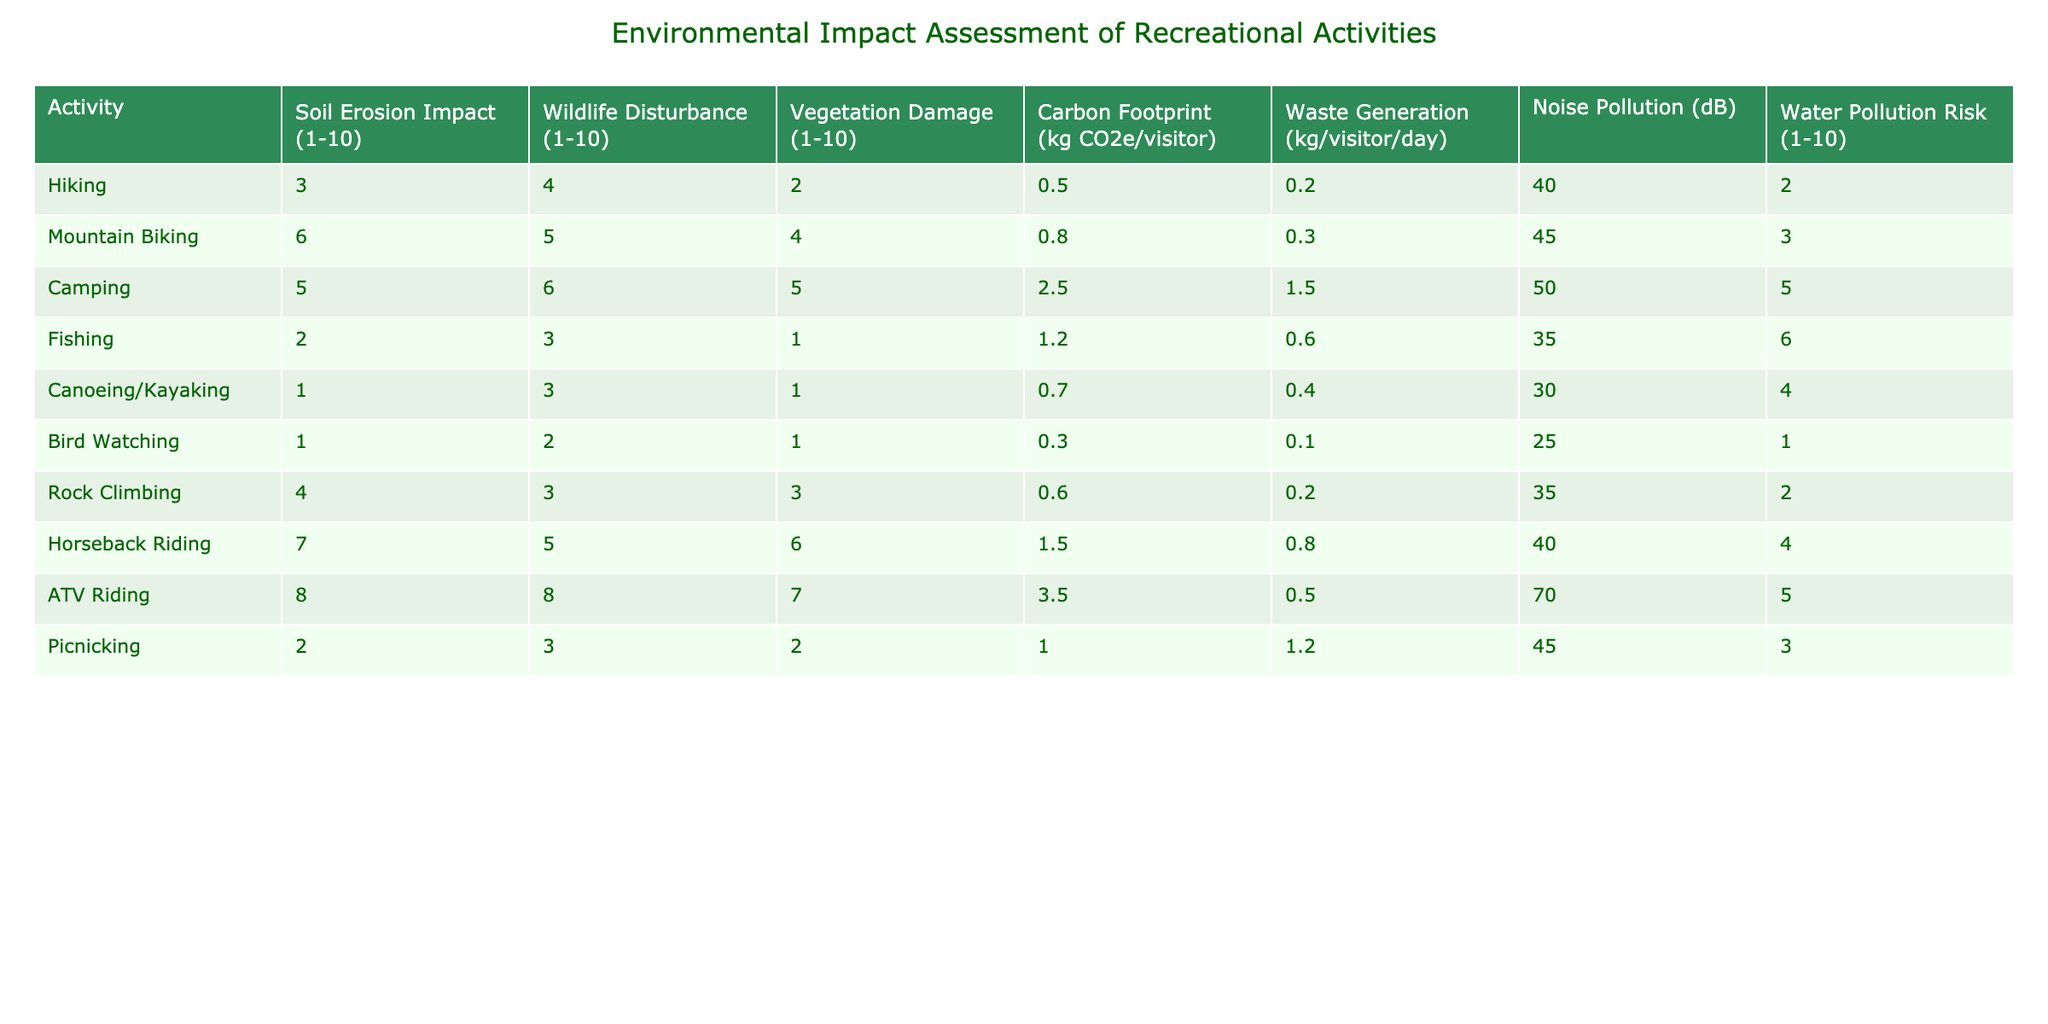What is the soil erosion impact of mountain biking? The table shows that the soil erosion impact rating for mountain biking is 6.
Answer: 6 Which activity has the highest carbon footprint per visitor? By examining the carbon footprint values in the table, ATV riding has the highest value at 3.5 kg CO2e per visitor.
Answer: 3.5 What is the average waste generation per visitor for all activities listed? First, sum the waste generation values: (0.2 + 0.3 + 1.5 + 0.6 + 0.4 + 0.1 + 0.2 + 0.8 + 0.5 + 1.2) = 5.8. There are 10 activities, so the average is 5.8 / 10 = 0.58 kg/visitor/day.
Answer: 0.58 kg/visitor/day Does bird watching have a higher wildlife disturbance impact than fishing? The wildlife disturbance impact for bird watching is 2, while for fishing it is 3. Since 2 is not greater than 3, the statement is false.
Answer: No Which activity generates the least noise pollution? The noise pollution levels for each activity reveal that bird watching has the lowest rating at 25 dB.
Answer: 25 dB What is the total vegetation damage score for horseback riding and camping combined? The vegetation damage for horseback riding is 6 and for camping is 5. Adding them together gives 6 + 5 = 11.
Answer: 11 How many activities have a water pollution risk rating of 5 or higher? Assessing the water pollution risk ratings, camping, ATV riding, and fishing have ratings of 5, thus there are 3 activities with a rating of 5 or higher.
Answer: 3 Is the carbon footprint of canoeing/kayaking less than that of hiking? Canoeing/kayaking has a carbon footprint of 0.7 while hiking has 0.5. Since 0.7 is not less than 0.5, the statement is false.
Answer: No What is the difference in soil erosion impact between ATV riding and hiking? The soil erosion impact for ATV riding is 8, while for hiking it is 3. The difference is calculated as 8 - 3 = 5.
Answer: 5 